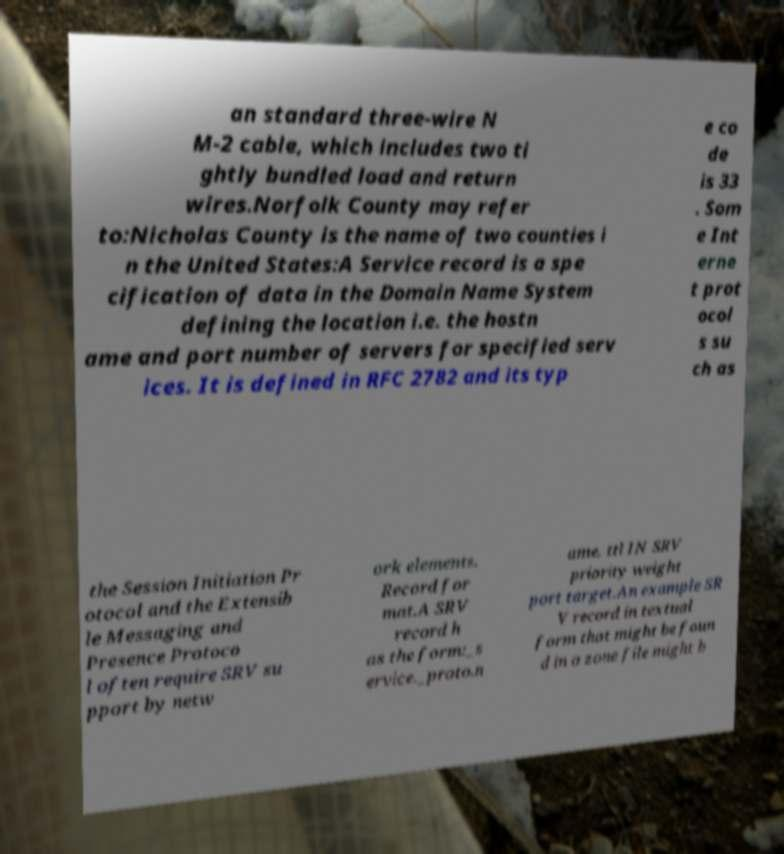There's text embedded in this image that I need extracted. Can you transcribe it verbatim? an standard three-wire N M-2 cable, which includes two ti ghtly bundled load and return wires.Norfolk County may refer to:Nicholas County is the name of two counties i n the United States:A Service record is a spe cification of data in the Domain Name System defining the location i.e. the hostn ame and port number of servers for specified serv ices. It is defined in RFC 2782 and its typ e co de is 33 . Som e Int erne t prot ocol s su ch as the Session Initiation Pr otocol and the Extensib le Messaging and Presence Protoco l often require SRV su pport by netw ork elements. Record for mat.A SRV record h as the form:_s ervice._proto.n ame. ttl IN SRV priority weight port target.An example SR V record in textual form that might be foun d in a zone file might b 